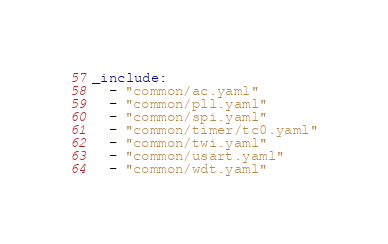Convert code to text. <code><loc_0><loc_0><loc_500><loc_500><_YAML_>_include:
  - "common/ac.yaml"
  - "common/pll.yaml"
  - "common/spi.yaml"
  - "common/timer/tc0.yaml"
  - "common/twi.yaml"
  - "common/usart.yaml"
  - "common/wdt.yaml"
</code> 